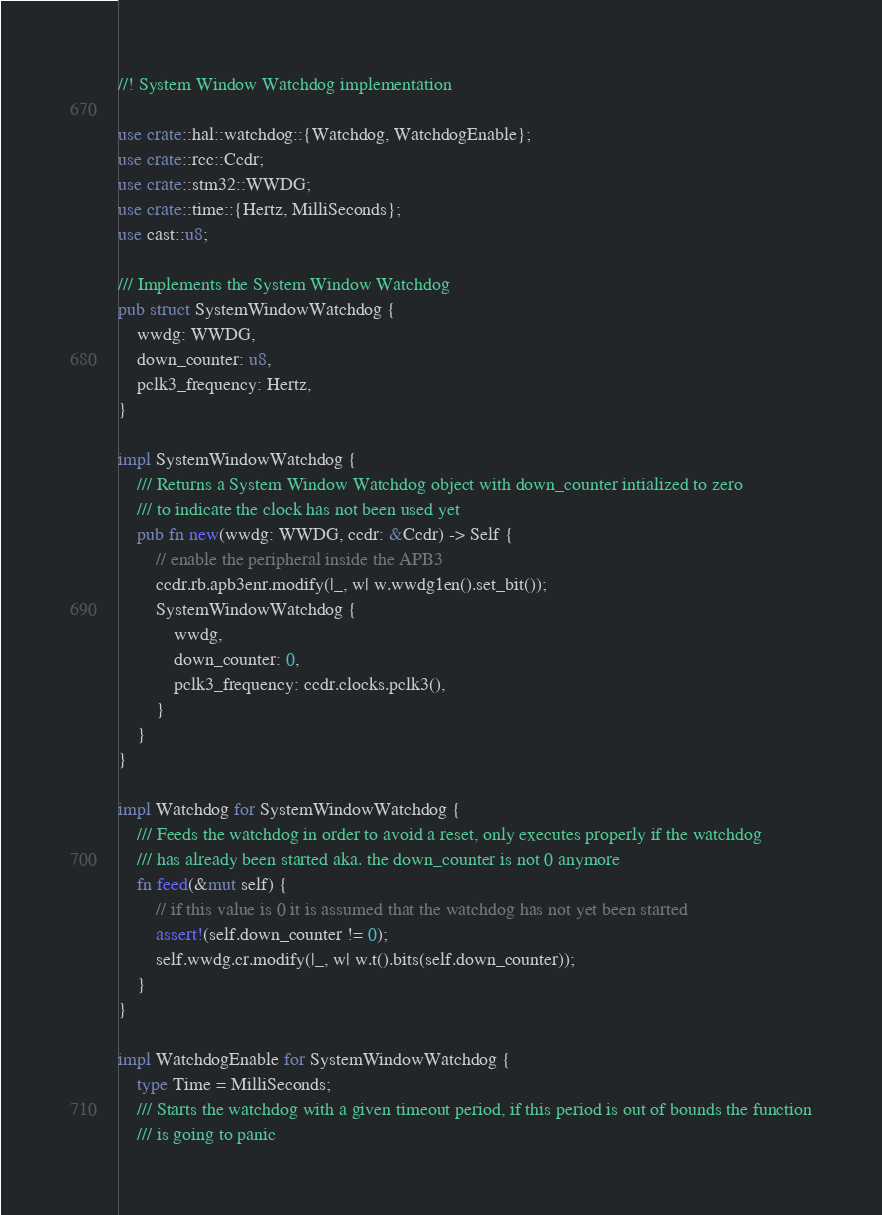Convert code to text. <code><loc_0><loc_0><loc_500><loc_500><_Rust_>//! System Window Watchdog implementation

use crate::hal::watchdog::{Watchdog, WatchdogEnable};
use crate::rcc::Ccdr;
use crate::stm32::WWDG;
use crate::time::{Hertz, MilliSeconds};
use cast::u8;

/// Implements the System Window Watchdog
pub struct SystemWindowWatchdog {
    wwdg: WWDG,
    down_counter: u8,
    pclk3_frequency: Hertz,
}

impl SystemWindowWatchdog {
    /// Returns a System Window Watchdog object with down_counter intialized to zero
    /// to indicate the clock has not been used yet
    pub fn new(wwdg: WWDG, ccdr: &Ccdr) -> Self {
        // enable the peripheral inside the APB3
        ccdr.rb.apb3enr.modify(|_, w| w.wwdg1en().set_bit());
        SystemWindowWatchdog {
            wwdg,
            down_counter: 0,
            pclk3_frequency: ccdr.clocks.pclk3(),
        }
    }
}

impl Watchdog for SystemWindowWatchdog {
    /// Feeds the watchdog in order to avoid a reset, only executes properly if the watchdog
    /// has already been started aka. the down_counter is not 0 anymore
    fn feed(&mut self) {
        // if this value is 0 it is assumed that the watchdog has not yet been started
        assert!(self.down_counter != 0);
        self.wwdg.cr.modify(|_, w| w.t().bits(self.down_counter));
    }
}

impl WatchdogEnable for SystemWindowWatchdog {
    type Time = MilliSeconds;
    /// Starts the watchdog with a given timeout period, if this period is out of bounds the function
    /// is going to panic</code> 